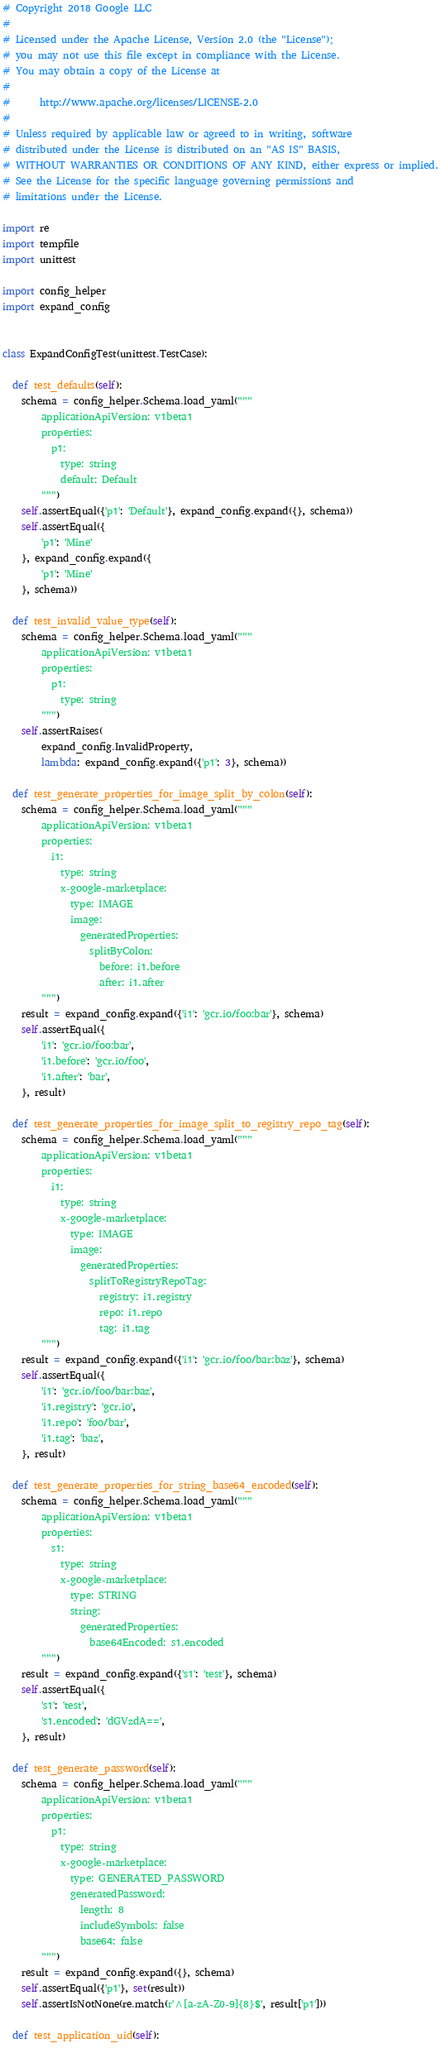Convert code to text. <code><loc_0><loc_0><loc_500><loc_500><_Python_># Copyright 2018 Google LLC
#
# Licensed under the Apache License, Version 2.0 (the "License");
# you may not use this file except in compliance with the License.
# You may obtain a copy of the License at
#
#      http://www.apache.org/licenses/LICENSE-2.0
#
# Unless required by applicable law or agreed to in writing, software
# distributed under the License is distributed on an "AS IS" BASIS,
# WITHOUT WARRANTIES OR CONDITIONS OF ANY KIND, either express or implied.
# See the License for the specific language governing permissions and
# limitations under the License.

import re
import tempfile
import unittest

import config_helper
import expand_config


class ExpandConfigTest(unittest.TestCase):

  def test_defaults(self):
    schema = config_helper.Schema.load_yaml("""
        applicationApiVersion: v1beta1
        properties:
          p1:
            type: string
            default: Default
        """)
    self.assertEqual({'p1': 'Default'}, expand_config.expand({}, schema))
    self.assertEqual({
        'p1': 'Mine'
    }, expand_config.expand({
        'p1': 'Mine'
    }, schema))

  def test_invalid_value_type(self):
    schema = config_helper.Schema.load_yaml("""
        applicationApiVersion: v1beta1
        properties:
          p1:
            type: string
        """)
    self.assertRaises(
        expand_config.InvalidProperty,
        lambda: expand_config.expand({'p1': 3}, schema))

  def test_generate_properties_for_image_split_by_colon(self):
    schema = config_helper.Schema.load_yaml("""
        applicationApiVersion: v1beta1
        properties:
          i1:
            type: string
            x-google-marketplace:
              type: IMAGE
              image:
                generatedProperties:
                  splitByColon:
                    before: i1.before
                    after: i1.after
        """)
    result = expand_config.expand({'i1': 'gcr.io/foo:bar'}, schema)
    self.assertEqual({
        'i1': 'gcr.io/foo:bar',
        'i1.before': 'gcr.io/foo',
        'i1.after': 'bar',
    }, result)

  def test_generate_properties_for_image_split_to_registry_repo_tag(self):
    schema = config_helper.Schema.load_yaml("""
        applicationApiVersion: v1beta1
        properties:
          i1:
            type: string
            x-google-marketplace:
              type: IMAGE
              image:
                generatedProperties:
                  splitToRegistryRepoTag:
                    registry: i1.registry
                    repo: i1.repo
                    tag: i1.tag
        """)
    result = expand_config.expand({'i1': 'gcr.io/foo/bar:baz'}, schema)
    self.assertEqual({
        'i1': 'gcr.io/foo/bar:baz',
        'i1.registry': 'gcr.io',
        'i1.repo': 'foo/bar',
        'i1.tag': 'baz',
    }, result)

  def test_generate_properties_for_string_base64_encoded(self):
    schema = config_helper.Schema.load_yaml("""
        applicationApiVersion: v1beta1
        properties:
          s1:
            type: string
            x-google-marketplace:
              type: STRING
              string:
                generatedProperties:
                  base64Encoded: s1.encoded
        """)
    result = expand_config.expand({'s1': 'test'}, schema)
    self.assertEqual({
        's1': 'test',
        's1.encoded': 'dGVzdA==',
    }, result)

  def test_generate_password(self):
    schema = config_helper.Schema.load_yaml("""
        applicationApiVersion: v1beta1
        properties:
          p1:
            type: string
            x-google-marketplace:
              type: GENERATED_PASSWORD
              generatedPassword:
                length: 8
                includeSymbols: false
                base64: false
        """)
    result = expand_config.expand({}, schema)
    self.assertEqual({'p1'}, set(result))
    self.assertIsNotNone(re.match(r'^[a-zA-Z0-9]{8}$', result['p1']))

  def test_application_uid(self):</code> 